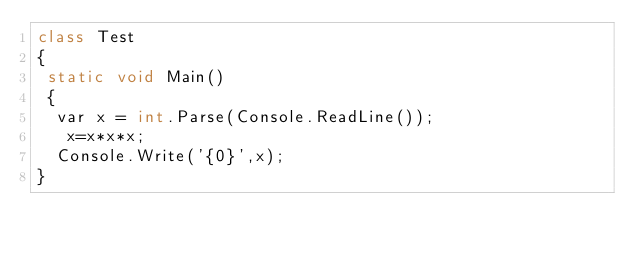<code> <loc_0><loc_0><loc_500><loc_500><_C#_>class Test
{
 static void Main()
 {
  var x = int.Parse(Console.ReadLine());
   x=x*x*x;
  Console.Write('{0}',x);
}</code> 